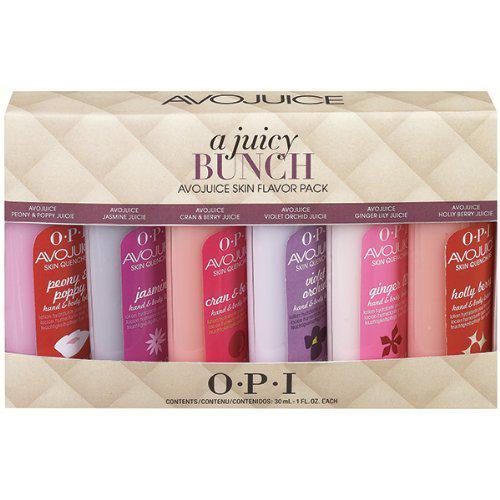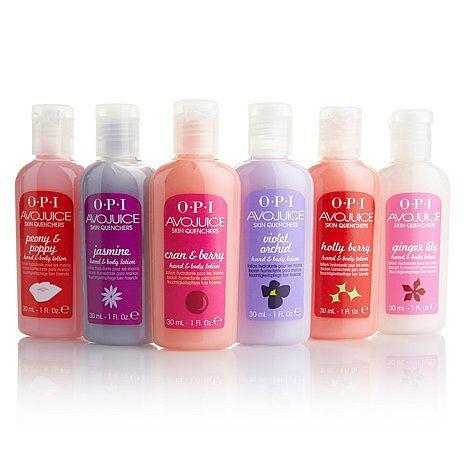The first image is the image on the left, the second image is the image on the right. Given the left and right images, does the statement "The left image features a single pump-top product." hold true? Answer yes or no. No. The first image is the image on the left, the second image is the image on the right. Evaluate the accuracy of this statement regarding the images: "At least four bottles of lotion are in one image, while the other image has just one pump bottle of lotion.". Is it true? Answer yes or no. No. 